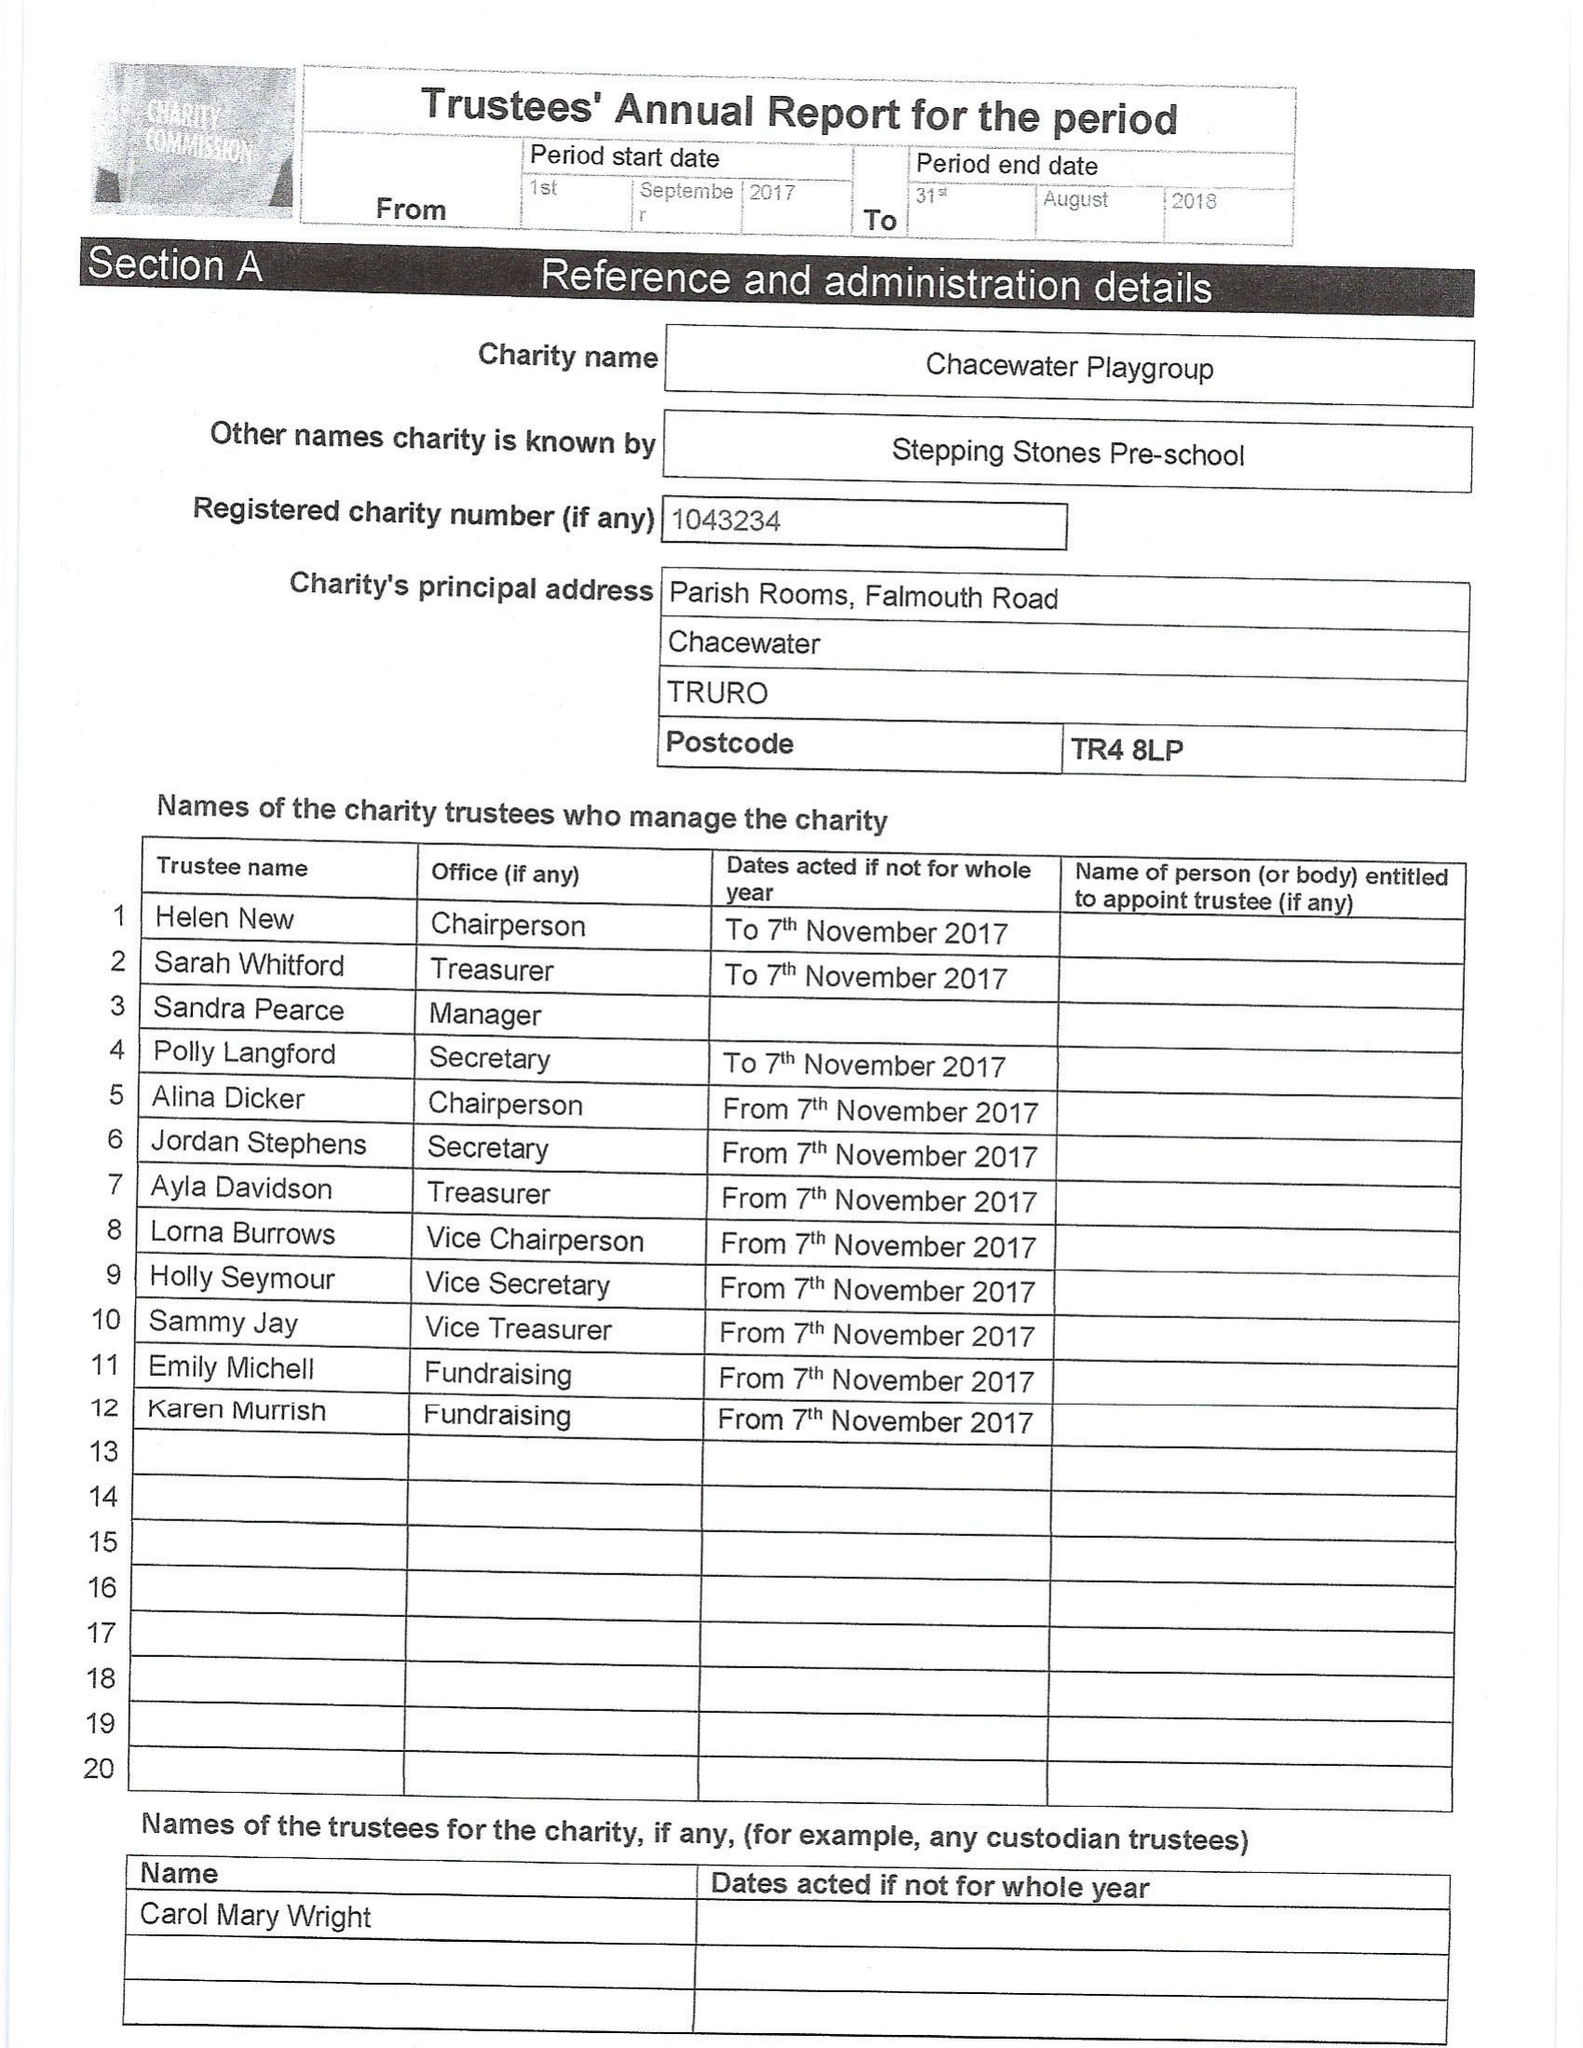What is the value for the address__postcode?
Answer the question using a single word or phrase. TR4 8LP 